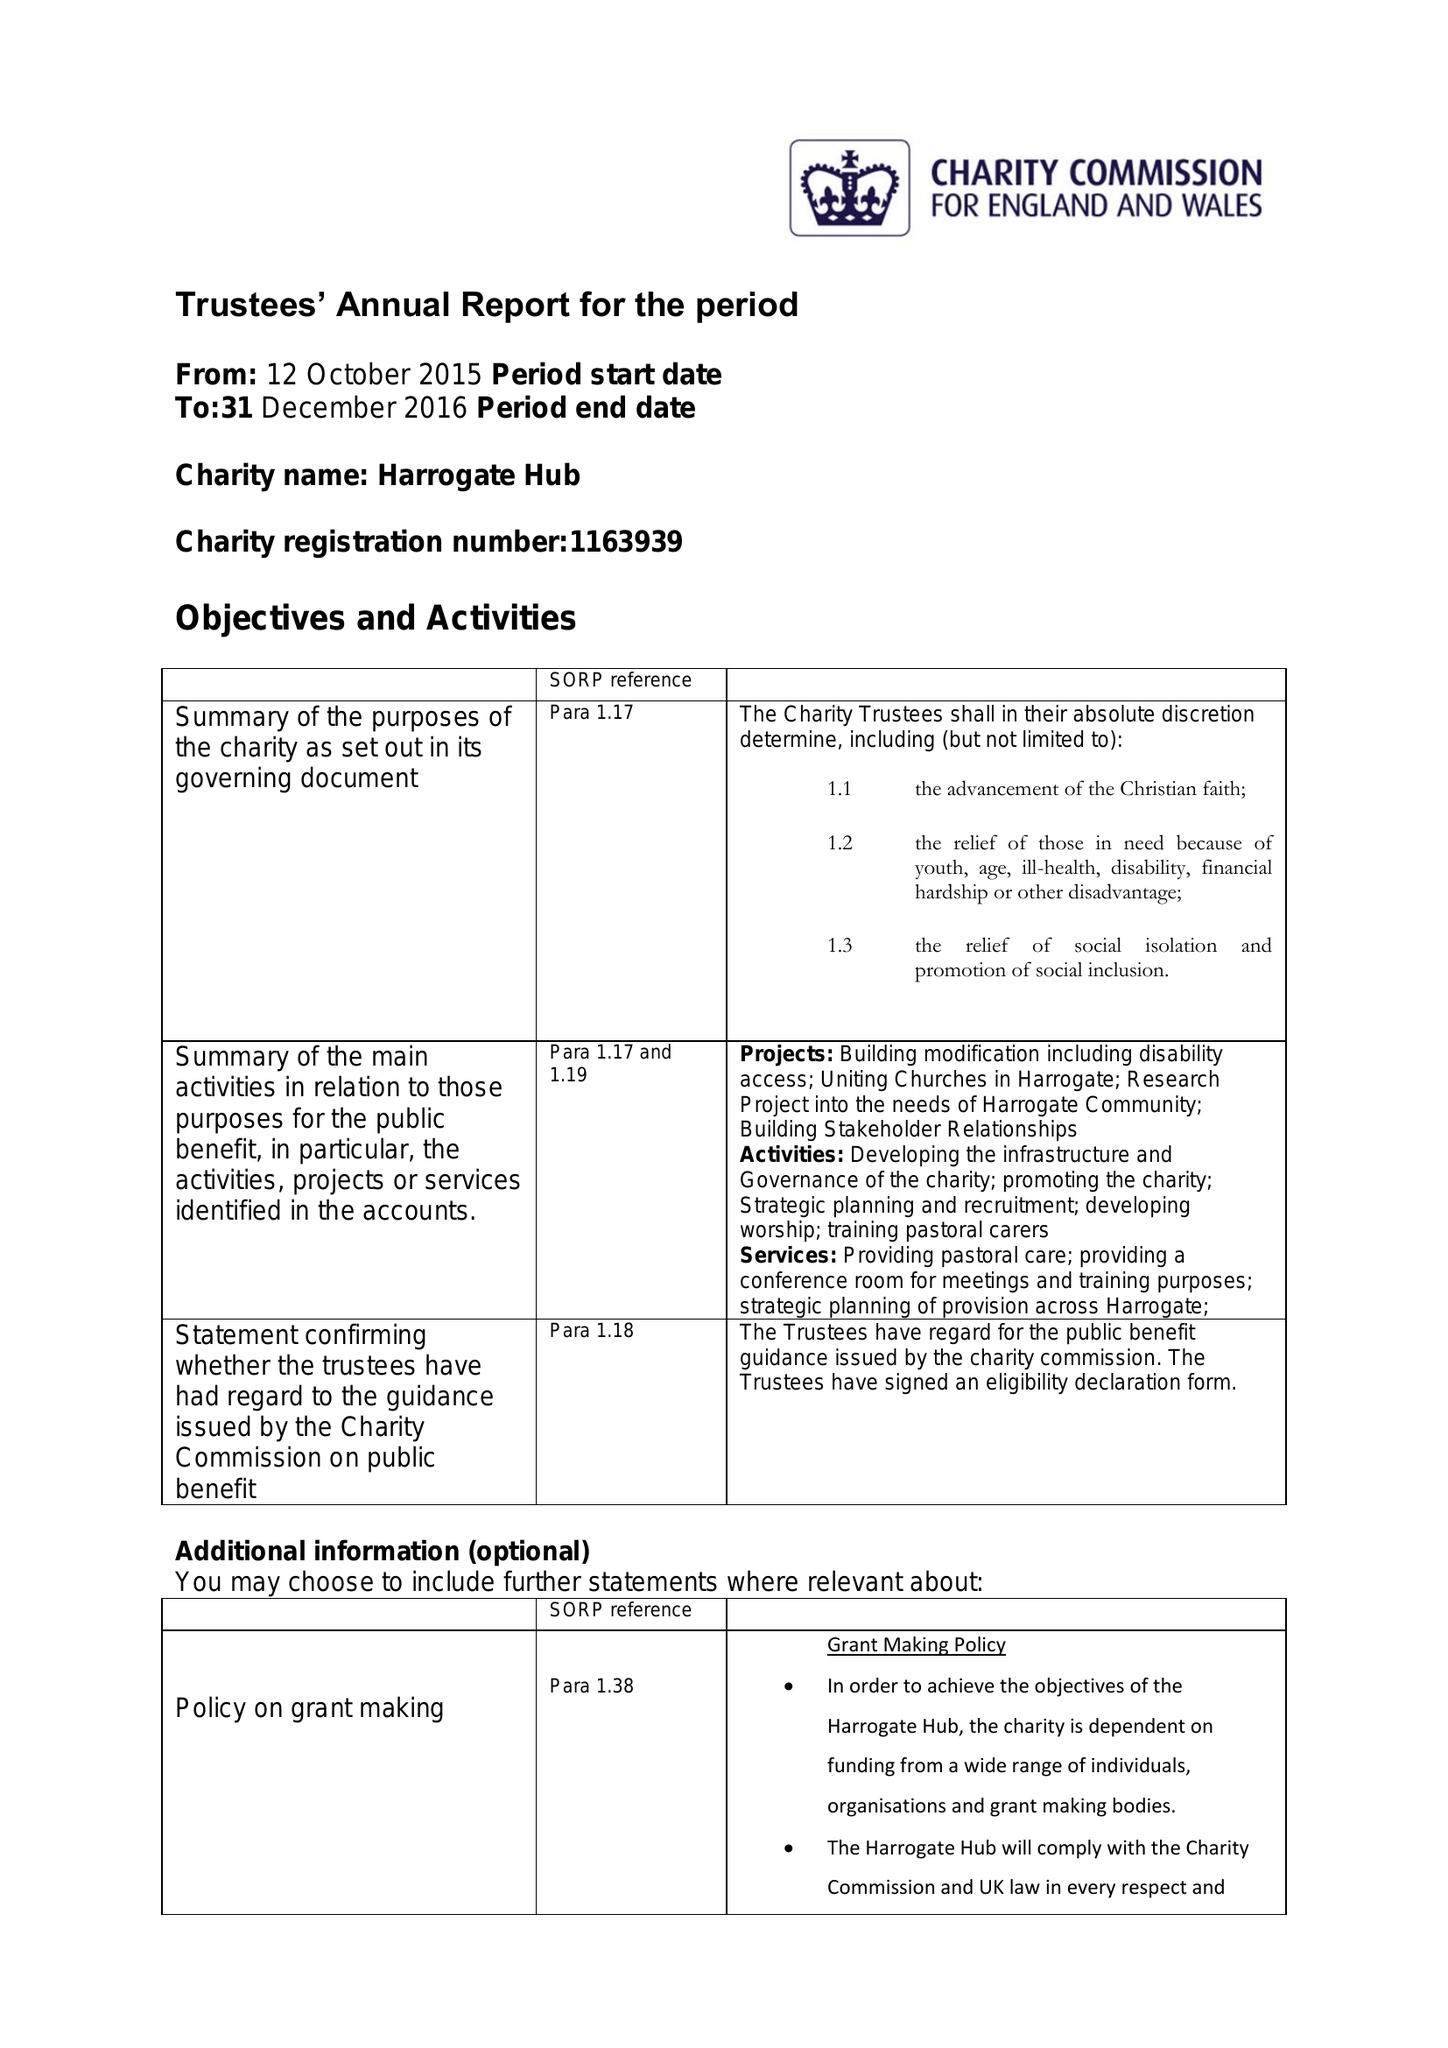What is the value for the address__postcode?
Answer the question using a single word or phrase. HG1 1PW 